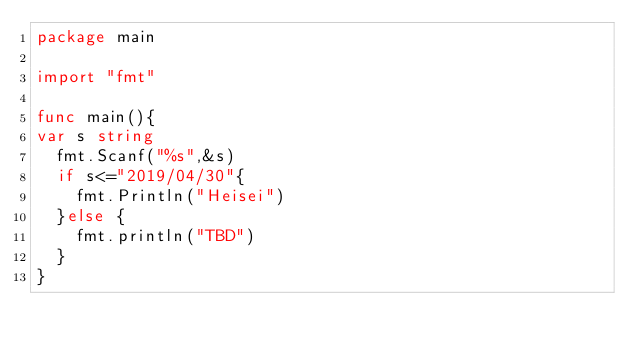Convert code to text. <code><loc_0><loc_0><loc_500><loc_500><_Go_>package main

import "fmt"

func main(){
var s string
  fmt.Scanf("%s",&s)
  if s<="2019/04/30"{
    fmt.Println("Heisei")
  }else {
    fmt.println("TBD")
  }
}</code> 